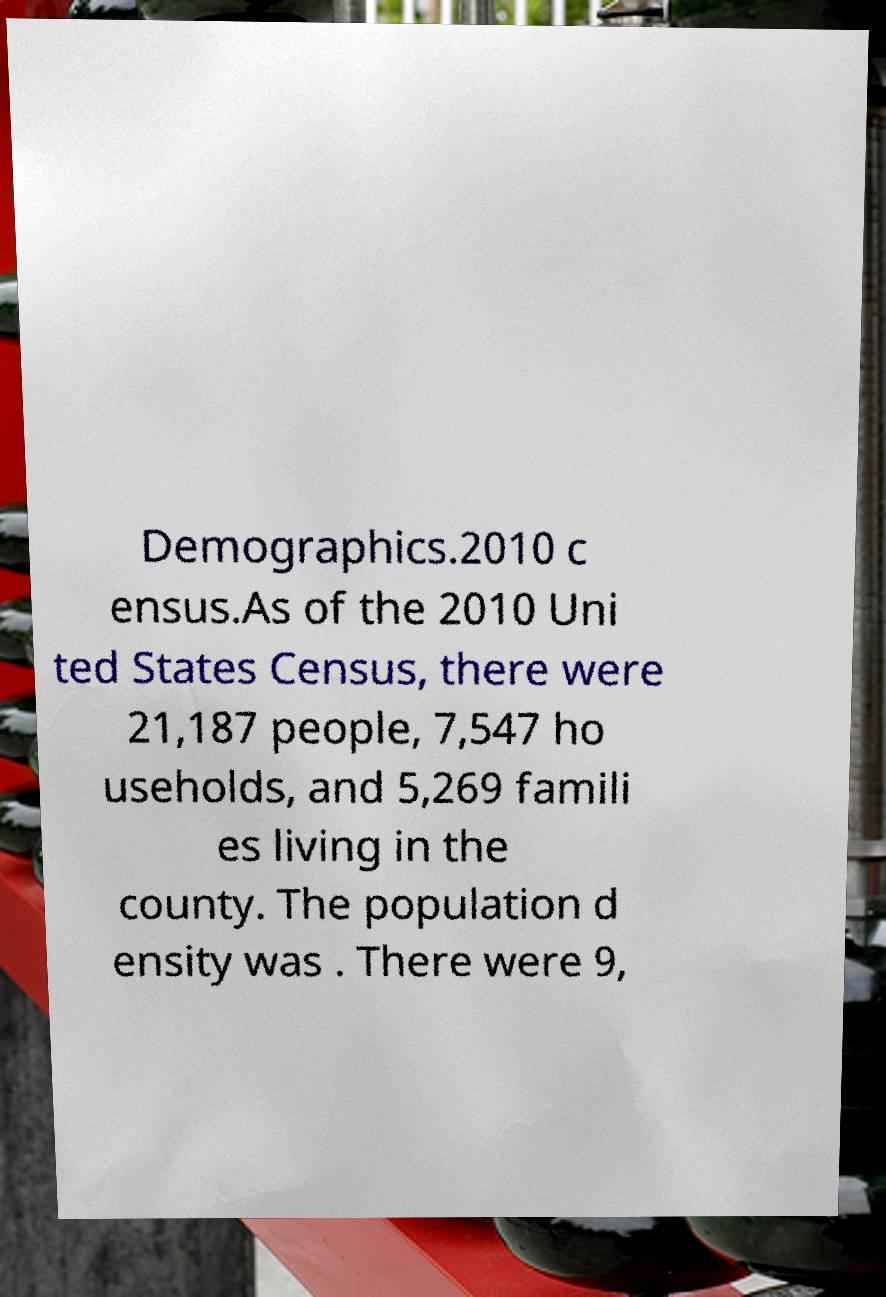Could you assist in decoding the text presented in this image and type it out clearly? Demographics.2010 c ensus.As of the 2010 Uni ted States Census, there were 21,187 people, 7,547 ho useholds, and 5,269 famili es living in the county. The population d ensity was . There were 9, 